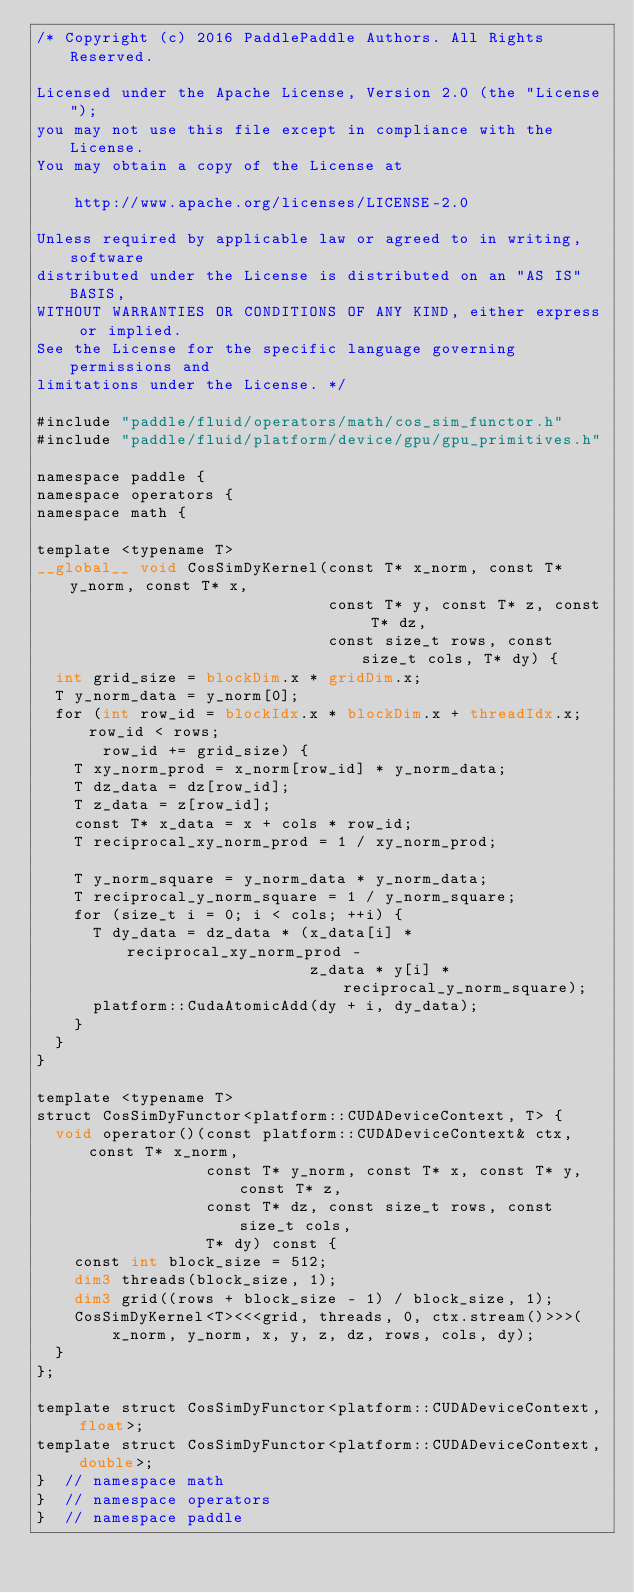Convert code to text. <code><loc_0><loc_0><loc_500><loc_500><_Cuda_>/* Copyright (c) 2016 PaddlePaddle Authors. All Rights Reserved.

Licensed under the Apache License, Version 2.0 (the "License");
you may not use this file except in compliance with the License.
You may obtain a copy of the License at

    http://www.apache.org/licenses/LICENSE-2.0

Unless required by applicable law or agreed to in writing, software
distributed under the License is distributed on an "AS IS" BASIS,
WITHOUT WARRANTIES OR CONDITIONS OF ANY KIND, either express or implied.
See the License for the specific language governing permissions and
limitations under the License. */

#include "paddle/fluid/operators/math/cos_sim_functor.h"
#include "paddle/fluid/platform/device/gpu/gpu_primitives.h"

namespace paddle {
namespace operators {
namespace math {

template <typename T>
__global__ void CosSimDyKernel(const T* x_norm, const T* y_norm, const T* x,
                               const T* y, const T* z, const T* dz,
                               const size_t rows, const size_t cols, T* dy) {
  int grid_size = blockDim.x * gridDim.x;
  T y_norm_data = y_norm[0];
  for (int row_id = blockIdx.x * blockDim.x + threadIdx.x; row_id < rows;
       row_id += grid_size) {
    T xy_norm_prod = x_norm[row_id] * y_norm_data;
    T dz_data = dz[row_id];
    T z_data = z[row_id];
    const T* x_data = x + cols * row_id;
    T reciprocal_xy_norm_prod = 1 / xy_norm_prod;

    T y_norm_square = y_norm_data * y_norm_data;
    T reciprocal_y_norm_square = 1 / y_norm_square;
    for (size_t i = 0; i < cols; ++i) {
      T dy_data = dz_data * (x_data[i] * reciprocal_xy_norm_prod -
                             z_data * y[i] * reciprocal_y_norm_square);
      platform::CudaAtomicAdd(dy + i, dy_data);
    }
  }
}

template <typename T>
struct CosSimDyFunctor<platform::CUDADeviceContext, T> {
  void operator()(const platform::CUDADeviceContext& ctx, const T* x_norm,
                  const T* y_norm, const T* x, const T* y, const T* z,
                  const T* dz, const size_t rows, const size_t cols,
                  T* dy) const {
    const int block_size = 512;
    dim3 threads(block_size, 1);
    dim3 grid((rows + block_size - 1) / block_size, 1);
    CosSimDyKernel<T><<<grid, threads, 0, ctx.stream()>>>(
        x_norm, y_norm, x, y, z, dz, rows, cols, dy);
  }
};

template struct CosSimDyFunctor<platform::CUDADeviceContext, float>;
template struct CosSimDyFunctor<platform::CUDADeviceContext, double>;
}  // namespace math
}  // namespace operators
}  // namespace paddle
</code> 